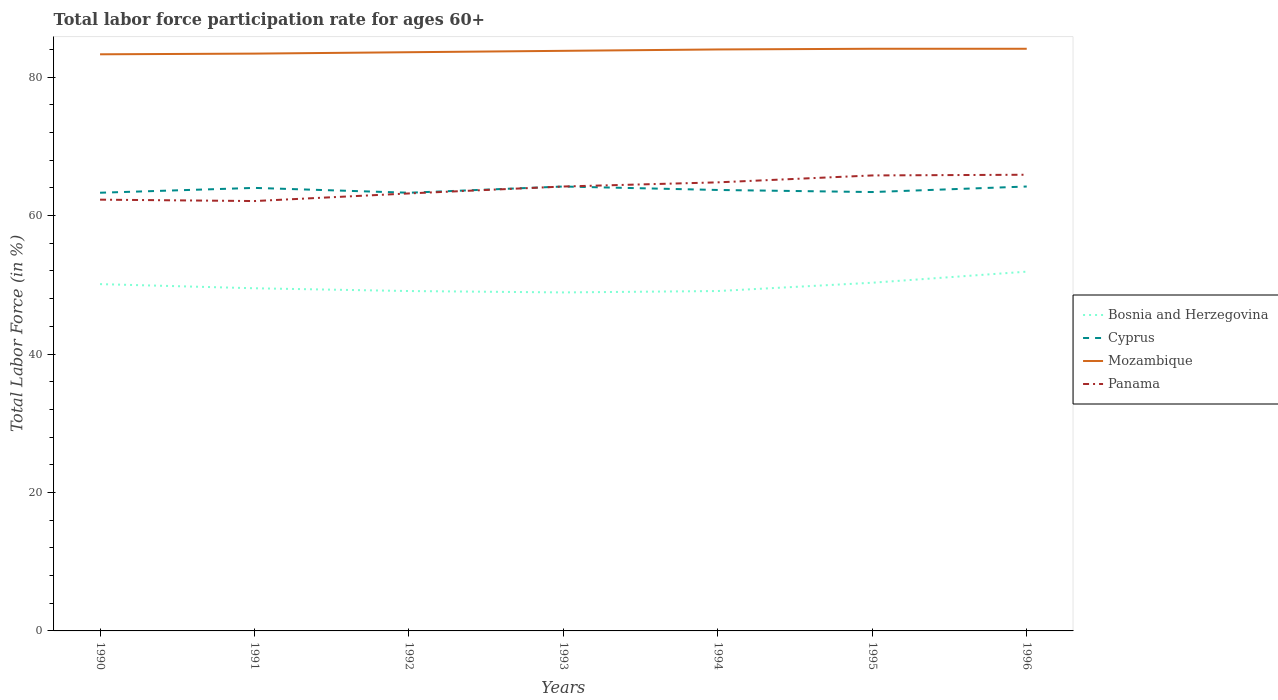How many different coloured lines are there?
Make the answer very short. 4. Does the line corresponding to Panama intersect with the line corresponding to Mozambique?
Your answer should be very brief. No. Is the number of lines equal to the number of legend labels?
Keep it short and to the point. Yes. Across all years, what is the maximum labor force participation rate in Bosnia and Herzegovina?
Your answer should be very brief. 48.9. What is the total labor force participation rate in Cyprus in the graph?
Provide a succinct answer. -0.1. What is the difference between the highest and the second highest labor force participation rate in Cyprus?
Provide a succinct answer. 0.9. What is the difference between two consecutive major ticks on the Y-axis?
Provide a succinct answer. 20. Are the values on the major ticks of Y-axis written in scientific E-notation?
Keep it short and to the point. No. Does the graph contain grids?
Provide a short and direct response. No. Where does the legend appear in the graph?
Give a very brief answer. Center right. How many legend labels are there?
Provide a short and direct response. 4. What is the title of the graph?
Give a very brief answer. Total labor force participation rate for ages 60+. Does "Korea (Democratic)" appear as one of the legend labels in the graph?
Give a very brief answer. No. What is the Total Labor Force (in %) of Bosnia and Herzegovina in 1990?
Give a very brief answer. 50.1. What is the Total Labor Force (in %) in Cyprus in 1990?
Your answer should be very brief. 63.3. What is the Total Labor Force (in %) of Mozambique in 1990?
Provide a short and direct response. 83.3. What is the Total Labor Force (in %) in Panama in 1990?
Your response must be concise. 62.3. What is the Total Labor Force (in %) of Bosnia and Herzegovina in 1991?
Offer a terse response. 49.5. What is the Total Labor Force (in %) of Mozambique in 1991?
Provide a short and direct response. 83.4. What is the Total Labor Force (in %) of Panama in 1991?
Offer a terse response. 62.1. What is the Total Labor Force (in %) in Bosnia and Herzegovina in 1992?
Provide a succinct answer. 49.1. What is the Total Labor Force (in %) in Cyprus in 1992?
Provide a short and direct response. 63.3. What is the Total Labor Force (in %) in Mozambique in 1992?
Keep it short and to the point. 83.6. What is the Total Labor Force (in %) in Panama in 1992?
Give a very brief answer. 63.2. What is the Total Labor Force (in %) in Bosnia and Herzegovina in 1993?
Provide a short and direct response. 48.9. What is the Total Labor Force (in %) in Cyprus in 1993?
Give a very brief answer. 64.2. What is the Total Labor Force (in %) in Mozambique in 1993?
Offer a terse response. 83.8. What is the Total Labor Force (in %) in Panama in 1993?
Provide a short and direct response. 64.2. What is the Total Labor Force (in %) in Bosnia and Herzegovina in 1994?
Your response must be concise. 49.1. What is the Total Labor Force (in %) in Cyprus in 1994?
Make the answer very short. 63.7. What is the Total Labor Force (in %) of Mozambique in 1994?
Ensure brevity in your answer.  84. What is the Total Labor Force (in %) in Panama in 1994?
Make the answer very short. 64.8. What is the Total Labor Force (in %) of Bosnia and Herzegovina in 1995?
Ensure brevity in your answer.  50.3. What is the Total Labor Force (in %) of Cyprus in 1995?
Offer a very short reply. 63.4. What is the Total Labor Force (in %) in Mozambique in 1995?
Make the answer very short. 84.1. What is the Total Labor Force (in %) in Panama in 1995?
Provide a short and direct response. 65.8. What is the Total Labor Force (in %) of Bosnia and Herzegovina in 1996?
Your answer should be very brief. 51.9. What is the Total Labor Force (in %) in Cyprus in 1996?
Make the answer very short. 64.2. What is the Total Labor Force (in %) of Mozambique in 1996?
Give a very brief answer. 84.1. What is the Total Labor Force (in %) of Panama in 1996?
Make the answer very short. 65.9. Across all years, what is the maximum Total Labor Force (in %) in Bosnia and Herzegovina?
Your answer should be very brief. 51.9. Across all years, what is the maximum Total Labor Force (in %) of Cyprus?
Your response must be concise. 64.2. Across all years, what is the maximum Total Labor Force (in %) of Mozambique?
Ensure brevity in your answer.  84.1. Across all years, what is the maximum Total Labor Force (in %) of Panama?
Give a very brief answer. 65.9. Across all years, what is the minimum Total Labor Force (in %) in Bosnia and Herzegovina?
Your response must be concise. 48.9. Across all years, what is the minimum Total Labor Force (in %) of Cyprus?
Your answer should be compact. 63.3. Across all years, what is the minimum Total Labor Force (in %) of Mozambique?
Your response must be concise. 83.3. Across all years, what is the minimum Total Labor Force (in %) in Panama?
Ensure brevity in your answer.  62.1. What is the total Total Labor Force (in %) in Bosnia and Herzegovina in the graph?
Your answer should be compact. 348.9. What is the total Total Labor Force (in %) in Cyprus in the graph?
Ensure brevity in your answer.  446.1. What is the total Total Labor Force (in %) of Mozambique in the graph?
Make the answer very short. 586.3. What is the total Total Labor Force (in %) of Panama in the graph?
Offer a very short reply. 448.3. What is the difference between the Total Labor Force (in %) in Bosnia and Herzegovina in 1990 and that in 1991?
Your answer should be compact. 0.6. What is the difference between the Total Labor Force (in %) of Bosnia and Herzegovina in 1990 and that in 1992?
Offer a very short reply. 1. What is the difference between the Total Labor Force (in %) of Bosnia and Herzegovina in 1990 and that in 1993?
Your answer should be compact. 1.2. What is the difference between the Total Labor Force (in %) in Cyprus in 1990 and that in 1994?
Your answer should be very brief. -0.4. What is the difference between the Total Labor Force (in %) of Mozambique in 1990 and that in 1994?
Your answer should be very brief. -0.7. What is the difference between the Total Labor Force (in %) in Bosnia and Herzegovina in 1990 and that in 1995?
Provide a short and direct response. -0.2. What is the difference between the Total Labor Force (in %) of Panama in 1990 and that in 1995?
Your response must be concise. -3.5. What is the difference between the Total Labor Force (in %) of Bosnia and Herzegovina in 1990 and that in 1996?
Offer a very short reply. -1.8. What is the difference between the Total Labor Force (in %) in Cyprus in 1990 and that in 1996?
Offer a terse response. -0.9. What is the difference between the Total Labor Force (in %) in Mozambique in 1990 and that in 1996?
Give a very brief answer. -0.8. What is the difference between the Total Labor Force (in %) in Bosnia and Herzegovina in 1991 and that in 1992?
Give a very brief answer. 0.4. What is the difference between the Total Labor Force (in %) of Cyprus in 1991 and that in 1992?
Keep it short and to the point. 0.7. What is the difference between the Total Labor Force (in %) in Panama in 1991 and that in 1992?
Your answer should be compact. -1.1. What is the difference between the Total Labor Force (in %) in Bosnia and Herzegovina in 1991 and that in 1993?
Give a very brief answer. 0.6. What is the difference between the Total Labor Force (in %) of Mozambique in 1991 and that in 1993?
Give a very brief answer. -0.4. What is the difference between the Total Labor Force (in %) of Bosnia and Herzegovina in 1991 and that in 1994?
Provide a succinct answer. 0.4. What is the difference between the Total Labor Force (in %) of Panama in 1991 and that in 1994?
Ensure brevity in your answer.  -2.7. What is the difference between the Total Labor Force (in %) of Bosnia and Herzegovina in 1991 and that in 1995?
Provide a short and direct response. -0.8. What is the difference between the Total Labor Force (in %) in Cyprus in 1991 and that in 1995?
Ensure brevity in your answer.  0.6. What is the difference between the Total Labor Force (in %) of Mozambique in 1991 and that in 1995?
Your answer should be compact. -0.7. What is the difference between the Total Labor Force (in %) of Bosnia and Herzegovina in 1991 and that in 1996?
Your response must be concise. -2.4. What is the difference between the Total Labor Force (in %) in Bosnia and Herzegovina in 1992 and that in 1993?
Your response must be concise. 0.2. What is the difference between the Total Labor Force (in %) of Panama in 1992 and that in 1993?
Ensure brevity in your answer.  -1. What is the difference between the Total Labor Force (in %) in Bosnia and Herzegovina in 1992 and that in 1994?
Ensure brevity in your answer.  0. What is the difference between the Total Labor Force (in %) in Panama in 1992 and that in 1994?
Provide a succinct answer. -1.6. What is the difference between the Total Labor Force (in %) of Cyprus in 1992 and that in 1995?
Offer a terse response. -0.1. What is the difference between the Total Labor Force (in %) in Bosnia and Herzegovina in 1992 and that in 1996?
Provide a short and direct response. -2.8. What is the difference between the Total Labor Force (in %) in Cyprus in 1992 and that in 1996?
Your response must be concise. -0.9. What is the difference between the Total Labor Force (in %) of Mozambique in 1993 and that in 1994?
Make the answer very short. -0.2. What is the difference between the Total Labor Force (in %) in Mozambique in 1993 and that in 1996?
Make the answer very short. -0.3. What is the difference between the Total Labor Force (in %) in Bosnia and Herzegovina in 1994 and that in 1995?
Keep it short and to the point. -1.2. What is the difference between the Total Labor Force (in %) of Bosnia and Herzegovina in 1994 and that in 1996?
Provide a succinct answer. -2.8. What is the difference between the Total Labor Force (in %) in Bosnia and Herzegovina in 1995 and that in 1996?
Your answer should be very brief. -1.6. What is the difference between the Total Labor Force (in %) of Cyprus in 1995 and that in 1996?
Provide a short and direct response. -0.8. What is the difference between the Total Labor Force (in %) in Mozambique in 1995 and that in 1996?
Offer a terse response. 0. What is the difference between the Total Labor Force (in %) of Bosnia and Herzegovina in 1990 and the Total Labor Force (in %) of Cyprus in 1991?
Ensure brevity in your answer.  -13.9. What is the difference between the Total Labor Force (in %) of Bosnia and Herzegovina in 1990 and the Total Labor Force (in %) of Mozambique in 1991?
Your answer should be very brief. -33.3. What is the difference between the Total Labor Force (in %) of Cyprus in 1990 and the Total Labor Force (in %) of Mozambique in 1991?
Provide a succinct answer. -20.1. What is the difference between the Total Labor Force (in %) in Cyprus in 1990 and the Total Labor Force (in %) in Panama in 1991?
Make the answer very short. 1.2. What is the difference between the Total Labor Force (in %) of Mozambique in 1990 and the Total Labor Force (in %) of Panama in 1991?
Your answer should be very brief. 21.2. What is the difference between the Total Labor Force (in %) in Bosnia and Herzegovina in 1990 and the Total Labor Force (in %) in Cyprus in 1992?
Give a very brief answer. -13.2. What is the difference between the Total Labor Force (in %) of Bosnia and Herzegovina in 1990 and the Total Labor Force (in %) of Mozambique in 1992?
Offer a very short reply. -33.5. What is the difference between the Total Labor Force (in %) of Cyprus in 1990 and the Total Labor Force (in %) of Mozambique in 1992?
Offer a terse response. -20.3. What is the difference between the Total Labor Force (in %) of Cyprus in 1990 and the Total Labor Force (in %) of Panama in 1992?
Give a very brief answer. 0.1. What is the difference between the Total Labor Force (in %) in Mozambique in 1990 and the Total Labor Force (in %) in Panama in 1992?
Keep it short and to the point. 20.1. What is the difference between the Total Labor Force (in %) in Bosnia and Herzegovina in 1990 and the Total Labor Force (in %) in Cyprus in 1993?
Give a very brief answer. -14.1. What is the difference between the Total Labor Force (in %) of Bosnia and Herzegovina in 1990 and the Total Labor Force (in %) of Mozambique in 1993?
Your answer should be compact. -33.7. What is the difference between the Total Labor Force (in %) in Bosnia and Herzegovina in 1990 and the Total Labor Force (in %) in Panama in 1993?
Make the answer very short. -14.1. What is the difference between the Total Labor Force (in %) of Cyprus in 1990 and the Total Labor Force (in %) of Mozambique in 1993?
Offer a terse response. -20.5. What is the difference between the Total Labor Force (in %) in Cyprus in 1990 and the Total Labor Force (in %) in Panama in 1993?
Ensure brevity in your answer.  -0.9. What is the difference between the Total Labor Force (in %) in Bosnia and Herzegovina in 1990 and the Total Labor Force (in %) in Cyprus in 1994?
Make the answer very short. -13.6. What is the difference between the Total Labor Force (in %) in Bosnia and Herzegovina in 1990 and the Total Labor Force (in %) in Mozambique in 1994?
Give a very brief answer. -33.9. What is the difference between the Total Labor Force (in %) in Bosnia and Herzegovina in 1990 and the Total Labor Force (in %) in Panama in 1994?
Keep it short and to the point. -14.7. What is the difference between the Total Labor Force (in %) of Cyprus in 1990 and the Total Labor Force (in %) of Mozambique in 1994?
Offer a very short reply. -20.7. What is the difference between the Total Labor Force (in %) in Cyprus in 1990 and the Total Labor Force (in %) in Panama in 1994?
Offer a very short reply. -1.5. What is the difference between the Total Labor Force (in %) in Bosnia and Herzegovina in 1990 and the Total Labor Force (in %) in Cyprus in 1995?
Keep it short and to the point. -13.3. What is the difference between the Total Labor Force (in %) of Bosnia and Herzegovina in 1990 and the Total Labor Force (in %) of Mozambique in 1995?
Provide a short and direct response. -34. What is the difference between the Total Labor Force (in %) of Bosnia and Herzegovina in 1990 and the Total Labor Force (in %) of Panama in 1995?
Your answer should be compact. -15.7. What is the difference between the Total Labor Force (in %) of Cyprus in 1990 and the Total Labor Force (in %) of Mozambique in 1995?
Your response must be concise. -20.8. What is the difference between the Total Labor Force (in %) of Cyprus in 1990 and the Total Labor Force (in %) of Panama in 1995?
Your response must be concise. -2.5. What is the difference between the Total Labor Force (in %) in Bosnia and Herzegovina in 1990 and the Total Labor Force (in %) in Cyprus in 1996?
Provide a short and direct response. -14.1. What is the difference between the Total Labor Force (in %) of Bosnia and Herzegovina in 1990 and the Total Labor Force (in %) of Mozambique in 1996?
Ensure brevity in your answer.  -34. What is the difference between the Total Labor Force (in %) of Bosnia and Herzegovina in 1990 and the Total Labor Force (in %) of Panama in 1996?
Offer a terse response. -15.8. What is the difference between the Total Labor Force (in %) in Cyprus in 1990 and the Total Labor Force (in %) in Mozambique in 1996?
Offer a terse response. -20.8. What is the difference between the Total Labor Force (in %) of Mozambique in 1990 and the Total Labor Force (in %) of Panama in 1996?
Make the answer very short. 17.4. What is the difference between the Total Labor Force (in %) in Bosnia and Herzegovina in 1991 and the Total Labor Force (in %) in Cyprus in 1992?
Provide a short and direct response. -13.8. What is the difference between the Total Labor Force (in %) of Bosnia and Herzegovina in 1991 and the Total Labor Force (in %) of Mozambique in 1992?
Ensure brevity in your answer.  -34.1. What is the difference between the Total Labor Force (in %) in Bosnia and Herzegovina in 1991 and the Total Labor Force (in %) in Panama in 1992?
Your response must be concise. -13.7. What is the difference between the Total Labor Force (in %) in Cyprus in 1991 and the Total Labor Force (in %) in Mozambique in 1992?
Make the answer very short. -19.6. What is the difference between the Total Labor Force (in %) in Mozambique in 1991 and the Total Labor Force (in %) in Panama in 1992?
Ensure brevity in your answer.  20.2. What is the difference between the Total Labor Force (in %) of Bosnia and Herzegovina in 1991 and the Total Labor Force (in %) of Cyprus in 1993?
Offer a terse response. -14.7. What is the difference between the Total Labor Force (in %) in Bosnia and Herzegovina in 1991 and the Total Labor Force (in %) in Mozambique in 1993?
Ensure brevity in your answer.  -34.3. What is the difference between the Total Labor Force (in %) in Bosnia and Herzegovina in 1991 and the Total Labor Force (in %) in Panama in 1993?
Make the answer very short. -14.7. What is the difference between the Total Labor Force (in %) in Cyprus in 1991 and the Total Labor Force (in %) in Mozambique in 1993?
Give a very brief answer. -19.8. What is the difference between the Total Labor Force (in %) of Mozambique in 1991 and the Total Labor Force (in %) of Panama in 1993?
Keep it short and to the point. 19.2. What is the difference between the Total Labor Force (in %) of Bosnia and Herzegovina in 1991 and the Total Labor Force (in %) of Cyprus in 1994?
Offer a terse response. -14.2. What is the difference between the Total Labor Force (in %) in Bosnia and Herzegovina in 1991 and the Total Labor Force (in %) in Mozambique in 1994?
Provide a succinct answer. -34.5. What is the difference between the Total Labor Force (in %) of Bosnia and Herzegovina in 1991 and the Total Labor Force (in %) of Panama in 1994?
Offer a very short reply. -15.3. What is the difference between the Total Labor Force (in %) in Mozambique in 1991 and the Total Labor Force (in %) in Panama in 1994?
Offer a very short reply. 18.6. What is the difference between the Total Labor Force (in %) of Bosnia and Herzegovina in 1991 and the Total Labor Force (in %) of Mozambique in 1995?
Keep it short and to the point. -34.6. What is the difference between the Total Labor Force (in %) of Bosnia and Herzegovina in 1991 and the Total Labor Force (in %) of Panama in 1995?
Provide a succinct answer. -16.3. What is the difference between the Total Labor Force (in %) in Cyprus in 1991 and the Total Labor Force (in %) in Mozambique in 1995?
Give a very brief answer. -20.1. What is the difference between the Total Labor Force (in %) of Bosnia and Herzegovina in 1991 and the Total Labor Force (in %) of Cyprus in 1996?
Keep it short and to the point. -14.7. What is the difference between the Total Labor Force (in %) of Bosnia and Herzegovina in 1991 and the Total Labor Force (in %) of Mozambique in 1996?
Provide a short and direct response. -34.6. What is the difference between the Total Labor Force (in %) in Bosnia and Herzegovina in 1991 and the Total Labor Force (in %) in Panama in 1996?
Offer a very short reply. -16.4. What is the difference between the Total Labor Force (in %) in Cyprus in 1991 and the Total Labor Force (in %) in Mozambique in 1996?
Your answer should be very brief. -20.1. What is the difference between the Total Labor Force (in %) of Cyprus in 1991 and the Total Labor Force (in %) of Panama in 1996?
Make the answer very short. -1.9. What is the difference between the Total Labor Force (in %) in Mozambique in 1991 and the Total Labor Force (in %) in Panama in 1996?
Offer a terse response. 17.5. What is the difference between the Total Labor Force (in %) of Bosnia and Herzegovina in 1992 and the Total Labor Force (in %) of Cyprus in 1993?
Make the answer very short. -15.1. What is the difference between the Total Labor Force (in %) of Bosnia and Herzegovina in 1992 and the Total Labor Force (in %) of Mozambique in 1993?
Give a very brief answer. -34.7. What is the difference between the Total Labor Force (in %) of Bosnia and Herzegovina in 1992 and the Total Labor Force (in %) of Panama in 1993?
Your answer should be compact. -15.1. What is the difference between the Total Labor Force (in %) in Cyprus in 1992 and the Total Labor Force (in %) in Mozambique in 1993?
Ensure brevity in your answer.  -20.5. What is the difference between the Total Labor Force (in %) in Cyprus in 1992 and the Total Labor Force (in %) in Panama in 1993?
Keep it short and to the point. -0.9. What is the difference between the Total Labor Force (in %) in Mozambique in 1992 and the Total Labor Force (in %) in Panama in 1993?
Your response must be concise. 19.4. What is the difference between the Total Labor Force (in %) in Bosnia and Herzegovina in 1992 and the Total Labor Force (in %) in Cyprus in 1994?
Keep it short and to the point. -14.6. What is the difference between the Total Labor Force (in %) of Bosnia and Herzegovina in 1992 and the Total Labor Force (in %) of Mozambique in 1994?
Your answer should be compact. -34.9. What is the difference between the Total Labor Force (in %) in Bosnia and Herzegovina in 1992 and the Total Labor Force (in %) in Panama in 1994?
Make the answer very short. -15.7. What is the difference between the Total Labor Force (in %) of Cyprus in 1992 and the Total Labor Force (in %) of Mozambique in 1994?
Your answer should be very brief. -20.7. What is the difference between the Total Labor Force (in %) of Mozambique in 1992 and the Total Labor Force (in %) of Panama in 1994?
Your answer should be compact. 18.8. What is the difference between the Total Labor Force (in %) of Bosnia and Herzegovina in 1992 and the Total Labor Force (in %) of Cyprus in 1995?
Make the answer very short. -14.3. What is the difference between the Total Labor Force (in %) in Bosnia and Herzegovina in 1992 and the Total Labor Force (in %) in Mozambique in 1995?
Ensure brevity in your answer.  -35. What is the difference between the Total Labor Force (in %) in Bosnia and Herzegovina in 1992 and the Total Labor Force (in %) in Panama in 1995?
Make the answer very short. -16.7. What is the difference between the Total Labor Force (in %) of Cyprus in 1992 and the Total Labor Force (in %) of Mozambique in 1995?
Offer a terse response. -20.8. What is the difference between the Total Labor Force (in %) in Cyprus in 1992 and the Total Labor Force (in %) in Panama in 1995?
Provide a succinct answer. -2.5. What is the difference between the Total Labor Force (in %) of Mozambique in 1992 and the Total Labor Force (in %) of Panama in 1995?
Ensure brevity in your answer.  17.8. What is the difference between the Total Labor Force (in %) of Bosnia and Herzegovina in 1992 and the Total Labor Force (in %) of Cyprus in 1996?
Your answer should be compact. -15.1. What is the difference between the Total Labor Force (in %) of Bosnia and Herzegovina in 1992 and the Total Labor Force (in %) of Mozambique in 1996?
Offer a very short reply. -35. What is the difference between the Total Labor Force (in %) of Bosnia and Herzegovina in 1992 and the Total Labor Force (in %) of Panama in 1996?
Provide a short and direct response. -16.8. What is the difference between the Total Labor Force (in %) of Cyprus in 1992 and the Total Labor Force (in %) of Mozambique in 1996?
Provide a short and direct response. -20.8. What is the difference between the Total Labor Force (in %) in Cyprus in 1992 and the Total Labor Force (in %) in Panama in 1996?
Ensure brevity in your answer.  -2.6. What is the difference between the Total Labor Force (in %) in Mozambique in 1992 and the Total Labor Force (in %) in Panama in 1996?
Offer a very short reply. 17.7. What is the difference between the Total Labor Force (in %) of Bosnia and Herzegovina in 1993 and the Total Labor Force (in %) of Cyprus in 1994?
Provide a succinct answer. -14.8. What is the difference between the Total Labor Force (in %) in Bosnia and Herzegovina in 1993 and the Total Labor Force (in %) in Mozambique in 1994?
Make the answer very short. -35.1. What is the difference between the Total Labor Force (in %) in Bosnia and Herzegovina in 1993 and the Total Labor Force (in %) in Panama in 1994?
Your response must be concise. -15.9. What is the difference between the Total Labor Force (in %) of Cyprus in 1993 and the Total Labor Force (in %) of Mozambique in 1994?
Keep it short and to the point. -19.8. What is the difference between the Total Labor Force (in %) of Cyprus in 1993 and the Total Labor Force (in %) of Panama in 1994?
Make the answer very short. -0.6. What is the difference between the Total Labor Force (in %) in Mozambique in 1993 and the Total Labor Force (in %) in Panama in 1994?
Your answer should be very brief. 19. What is the difference between the Total Labor Force (in %) in Bosnia and Herzegovina in 1993 and the Total Labor Force (in %) in Cyprus in 1995?
Provide a short and direct response. -14.5. What is the difference between the Total Labor Force (in %) of Bosnia and Herzegovina in 1993 and the Total Labor Force (in %) of Mozambique in 1995?
Provide a short and direct response. -35.2. What is the difference between the Total Labor Force (in %) in Bosnia and Herzegovina in 1993 and the Total Labor Force (in %) in Panama in 1995?
Your response must be concise. -16.9. What is the difference between the Total Labor Force (in %) in Cyprus in 1993 and the Total Labor Force (in %) in Mozambique in 1995?
Offer a terse response. -19.9. What is the difference between the Total Labor Force (in %) in Bosnia and Herzegovina in 1993 and the Total Labor Force (in %) in Cyprus in 1996?
Your answer should be very brief. -15.3. What is the difference between the Total Labor Force (in %) in Bosnia and Herzegovina in 1993 and the Total Labor Force (in %) in Mozambique in 1996?
Your answer should be compact. -35.2. What is the difference between the Total Labor Force (in %) of Bosnia and Herzegovina in 1993 and the Total Labor Force (in %) of Panama in 1996?
Your response must be concise. -17. What is the difference between the Total Labor Force (in %) of Cyprus in 1993 and the Total Labor Force (in %) of Mozambique in 1996?
Ensure brevity in your answer.  -19.9. What is the difference between the Total Labor Force (in %) of Cyprus in 1993 and the Total Labor Force (in %) of Panama in 1996?
Your answer should be compact. -1.7. What is the difference between the Total Labor Force (in %) in Mozambique in 1993 and the Total Labor Force (in %) in Panama in 1996?
Your answer should be compact. 17.9. What is the difference between the Total Labor Force (in %) in Bosnia and Herzegovina in 1994 and the Total Labor Force (in %) in Cyprus in 1995?
Your response must be concise. -14.3. What is the difference between the Total Labor Force (in %) in Bosnia and Herzegovina in 1994 and the Total Labor Force (in %) in Mozambique in 1995?
Your answer should be compact. -35. What is the difference between the Total Labor Force (in %) in Bosnia and Herzegovina in 1994 and the Total Labor Force (in %) in Panama in 1995?
Your answer should be compact. -16.7. What is the difference between the Total Labor Force (in %) of Cyprus in 1994 and the Total Labor Force (in %) of Mozambique in 1995?
Make the answer very short. -20.4. What is the difference between the Total Labor Force (in %) in Mozambique in 1994 and the Total Labor Force (in %) in Panama in 1995?
Give a very brief answer. 18.2. What is the difference between the Total Labor Force (in %) in Bosnia and Herzegovina in 1994 and the Total Labor Force (in %) in Cyprus in 1996?
Keep it short and to the point. -15.1. What is the difference between the Total Labor Force (in %) in Bosnia and Herzegovina in 1994 and the Total Labor Force (in %) in Mozambique in 1996?
Provide a short and direct response. -35. What is the difference between the Total Labor Force (in %) in Bosnia and Herzegovina in 1994 and the Total Labor Force (in %) in Panama in 1996?
Your answer should be very brief. -16.8. What is the difference between the Total Labor Force (in %) of Cyprus in 1994 and the Total Labor Force (in %) of Mozambique in 1996?
Make the answer very short. -20.4. What is the difference between the Total Labor Force (in %) of Bosnia and Herzegovina in 1995 and the Total Labor Force (in %) of Mozambique in 1996?
Give a very brief answer. -33.8. What is the difference between the Total Labor Force (in %) of Bosnia and Herzegovina in 1995 and the Total Labor Force (in %) of Panama in 1996?
Your answer should be very brief. -15.6. What is the difference between the Total Labor Force (in %) in Cyprus in 1995 and the Total Labor Force (in %) in Mozambique in 1996?
Offer a very short reply. -20.7. What is the difference between the Total Labor Force (in %) of Cyprus in 1995 and the Total Labor Force (in %) of Panama in 1996?
Offer a terse response. -2.5. What is the average Total Labor Force (in %) of Bosnia and Herzegovina per year?
Provide a succinct answer. 49.84. What is the average Total Labor Force (in %) of Cyprus per year?
Offer a very short reply. 63.73. What is the average Total Labor Force (in %) of Mozambique per year?
Ensure brevity in your answer.  83.76. What is the average Total Labor Force (in %) in Panama per year?
Your response must be concise. 64.04. In the year 1990, what is the difference between the Total Labor Force (in %) in Bosnia and Herzegovina and Total Labor Force (in %) in Mozambique?
Make the answer very short. -33.2. In the year 1990, what is the difference between the Total Labor Force (in %) of Cyprus and Total Labor Force (in %) of Panama?
Provide a succinct answer. 1. In the year 1990, what is the difference between the Total Labor Force (in %) in Mozambique and Total Labor Force (in %) in Panama?
Your answer should be compact. 21. In the year 1991, what is the difference between the Total Labor Force (in %) in Bosnia and Herzegovina and Total Labor Force (in %) in Mozambique?
Give a very brief answer. -33.9. In the year 1991, what is the difference between the Total Labor Force (in %) in Bosnia and Herzegovina and Total Labor Force (in %) in Panama?
Provide a succinct answer. -12.6. In the year 1991, what is the difference between the Total Labor Force (in %) in Cyprus and Total Labor Force (in %) in Mozambique?
Keep it short and to the point. -19.4. In the year 1991, what is the difference between the Total Labor Force (in %) in Mozambique and Total Labor Force (in %) in Panama?
Provide a short and direct response. 21.3. In the year 1992, what is the difference between the Total Labor Force (in %) of Bosnia and Herzegovina and Total Labor Force (in %) of Mozambique?
Your response must be concise. -34.5. In the year 1992, what is the difference between the Total Labor Force (in %) in Bosnia and Herzegovina and Total Labor Force (in %) in Panama?
Your answer should be compact. -14.1. In the year 1992, what is the difference between the Total Labor Force (in %) in Cyprus and Total Labor Force (in %) in Mozambique?
Your answer should be very brief. -20.3. In the year 1992, what is the difference between the Total Labor Force (in %) in Mozambique and Total Labor Force (in %) in Panama?
Your answer should be compact. 20.4. In the year 1993, what is the difference between the Total Labor Force (in %) of Bosnia and Herzegovina and Total Labor Force (in %) of Cyprus?
Provide a succinct answer. -15.3. In the year 1993, what is the difference between the Total Labor Force (in %) in Bosnia and Herzegovina and Total Labor Force (in %) in Mozambique?
Make the answer very short. -34.9. In the year 1993, what is the difference between the Total Labor Force (in %) in Bosnia and Herzegovina and Total Labor Force (in %) in Panama?
Make the answer very short. -15.3. In the year 1993, what is the difference between the Total Labor Force (in %) in Cyprus and Total Labor Force (in %) in Mozambique?
Ensure brevity in your answer.  -19.6. In the year 1993, what is the difference between the Total Labor Force (in %) in Mozambique and Total Labor Force (in %) in Panama?
Make the answer very short. 19.6. In the year 1994, what is the difference between the Total Labor Force (in %) in Bosnia and Herzegovina and Total Labor Force (in %) in Cyprus?
Your response must be concise. -14.6. In the year 1994, what is the difference between the Total Labor Force (in %) of Bosnia and Herzegovina and Total Labor Force (in %) of Mozambique?
Provide a succinct answer. -34.9. In the year 1994, what is the difference between the Total Labor Force (in %) of Bosnia and Herzegovina and Total Labor Force (in %) of Panama?
Make the answer very short. -15.7. In the year 1994, what is the difference between the Total Labor Force (in %) in Cyprus and Total Labor Force (in %) in Mozambique?
Offer a terse response. -20.3. In the year 1995, what is the difference between the Total Labor Force (in %) in Bosnia and Herzegovina and Total Labor Force (in %) in Mozambique?
Offer a terse response. -33.8. In the year 1995, what is the difference between the Total Labor Force (in %) in Bosnia and Herzegovina and Total Labor Force (in %) in Panama?
Keep it short and to the point. -15.5. In the year 1995, what is the difference between the Total Labor Force (in %) of Cyprus and Total Labor Force (in %) of Mozambique?
Your answer should be very brief. -20.7. In the year 1995, what is the difference between the Total Labor Force (in %) in Cyprus and Total Labor Force (in %) in Panama?
Your answer should be compact. -2.4. In the year 1995, what is the difference between the Total Labor Force (in %) in Mozambique and Total Labor Force (in %) in Panama?
Your answer should be very brief. 18.3. In the year 1996, what is the difference between the Total Labor Force (in %) of Bosnia and Herzegovina and Total Labor Force (in %) of Cyprus?
Ensure brevity in your answer.  -12.3. In the year 1996, what is the difference between the Total Labor Force (in %) in Bosnia and Herzegovina and Total Labor Force (in %) in Mozambique?
Ensure brevity in your answer.  -32.2. In the year 1996, what is the difference between the Total Labor Force (in %) in Cyprus and Total Labor Force (in %) in Mozambique?
Offer a terse response. -19.9. In the year 1996, what is the difference between the Total Labor Force (in %) in Cyprus and Total Labor Force (in %) in Panama?
Your response must be concise. -1.7. In the year 1996, what is the difference between the Total Labor Force (in %) of Mozambique and Total Labor Force (in %) of Panama?
Make the answer very short. 18.2. What is the ratio of the Total Labor Force (in %) in Bosnia and Herzegovina in 1990 to that in 1991?
Offer a very short reply. 1.01. What is the ratio of the Total Labor Force (in %) in Cyprus in 1990 to that in 1991?
Give a very brief answer. 0.99. What is the ratio of the Total Labor Force (in %) of Bosnia and Herzegovina in 1990 to that in 1992?
Provide a succinct answer. 1.02. What is the ratio of the Total Labor Force (in %) in Cyprus in 1990 to that in 1992?
Keep it short and to the point. 1. What is the ratio of the Total Labor Force (in %) in Mozambique in 1990 to that in 1992?
Your answer should be very brief. 1. What is the ratio of the Total Labor Force (in %) of Panama in 1990 to that in 1992?
Provide a succinct answer. 0.99. What is the ratio of the Total Labor Force (in %) of Bosnia and Herzegovina in 1990 to that in 1993?
Your answer should be very brief. 1.02. What is the ratio of the Total Labor Force (in %) of Cyprus in 1990 to that in 1993?
Your answer should be compact. 0.99. What is the ratio of the Total Labor Force (in %) of Panama in 1990 to that in 1993?
Keep it short and to the point. 0.97. What is the ratio of the Total Labor Force (in %) in Bosnia and Herzegovina in 1990 to that in 1994?
Provide a succinct answer. 1.02. What is the ratio of the Total Labor Force (in %) of Mozambique in 1990 to that in 1994?
Give a very brief answer. 0.99. What is the ratio of the Total Labor Force (in %) in Panama in 1990 to that in 1994?
Your answer should be compact. 0.96. What is the ratio of the Total Labor Force (in %) in Cyprus in 1990 to that in 1995?
Ensure brevity in your answer.  1. What is the ratio of the Total Labor Force (in %) in Mozambique in 1990 to that in 1995?
Your answer should be compact. 0.99. What is the ratio of the Total Labor Force (in %) in Panama in 1990 to that in 1995?
Ensure brevity in your answer.  0.95. What is the ratio of the Total Labor Force (in %) in Bosnia and Herzegovina in 1990 to that in 1996?
Ensure brevity in your answer.  0.97. What is the ratio of the Total Labor Force (in %) in Mozambique in 1990 to that in 1996?
Your response must be concise. 0.99. What is the ratio of the Total Labor Force (in %) of Panama in 1990 to that in 1996?
Keep it short and to the point. 0.95. What is the ratio of the Total Labor Force (in %) of Cyprus in 1991 to that in 1992?
Your answer should be compact. 1.01. What is the ratio of the Total Labor Force (in %) of Panama in 1991 to that in 1992?
Provide a succinct answer. 0.98. What is the ratio of the Total Labor Force (in %) in Bosnia and Herzegovina in 1991 to that in 1993?
Your answer should be very brief. 1.01. What is the ratio of the Total Labor Force (in %) of Panama in 1991 to that in 1993?
Provide a succinct answer. 0.97. What is the ratio of the Total Labor Force (in %) of Panama in 1991 to that in 1994?
Your response must be concise. 0.96. What is the ratio of the Total Labor Force (in %) in Bosnia and Herzegovina in 1991 to that in 1995?
Provide a succinct answer. 0.98. What is the ratio of the Total Labor Force (in %) of Cyprus in 1991 to that in 1995?
Your answer should be very brief. 1.01. What is the ratio of the Total Labor Force (in %) of Panama in 1991 to that in 1995?
Provide a succinct answer. 0.94. What is the ratio of the Total Labor Force (in %) in Bosnia and Herzegovina in 1991 to that in 1996?
Give a very brief answer. 0.95. What is the ratio of the Total Labor Force (in %) of Panama in 1991 to that in 1996?
Make the answer very short. 0.94. What is the ratio of the Total Labor Force (in %) of Bosnia and Herzegovina in 1992 to that in 1993?
Offer a terse response. 1. What is the ratio of the Total Labor Force (in %) of Mozambique in 1992 to that in 1993?
Your answer should be very brief. 1. What is the ratio of the Total Labor Force (in %) in Panama in 1992 to that in 1993?
Your response must be concise. 0.98. What is the ratio of the Total Labor Force (in %) of Cyprus in 1992 to that in 1994?
Provide a succinct answer. 0.99. What is the ratio of the Total Labor Force (in %) of Mozambique in 1992 to that in 1994?
Ensure brevity in your answer.  1. What is the ratio of the Total Labor Force (in %) of Panama in 1992 to that in 1994?
Make the answer very short. 0.98. What is the ratio of the Total Labor Force (in %) in Bosnia and Herzegovina in 1992 to that in 1995?
Provide a short and direct response. 0.98. What is the ratio of the Total Labor Force (in %) of Cyprus in 1992 to that in 1995?
Your answer should be compact. 1. What is the ratio of the Total Labor Force (in %) of Mozambique in 1992 to that in 1995?
Your response must be concise. 0.99. What is the ratio of the Total Labor Force (in %) of Panama in 1992 to that in 1995?
Make the answer very short. 0.96. What is the ratio of the Total Labor Force (in %) in Bosnia and Herzegovina in 1992 to that in 1996?
Your response must be concise. 0.95. What is the ratio of the Total Labor Force (in %) of Cyprus in 1993 to that in 1994?
Make the answer very short. 1.01. What is the ratio of the Total Labor Force (in %) of Panama in 1993 to that in 1994?
Provide a succinct answer. 0.99. What is the ratio of the Total Labor Force (in %) of Bosnia and Herzegovina in 1993 to that in 1995?
Give a very brief answer. 0.97. What is the ratio of the Total Labor Force (in %) of Cyprus in 1993 to that in 1995?
Provide a short and direct response. 1.01. What is the ratio of the Total Labor Force (in %) in Mozambique in 1993 to that in 1995?
Give a very brief answer. 1. What is the ratio of the Total Labor Force (in %) in Panama in 1993 to that in 1995?
Offer a very short reply. 0.98. What is the ratio of the Total Labor Force (in %) of Bosnia and Herzegovina in 1993 to that in 1996?
Provide a short and direct response. 0.94. What is the ratio of the Total Labor Force (in %) in Panama in 1993 to that in 1996?
Keep it short and to the point. 0.97. What is the ratio of the Total Labor Force (in %) of Bosnia and Herzegovina in 1994 to that in 1995?
Ensure brevity in your answer.  0.98. What is the ratio of the Total Labor Force (in %) in Cyprus in 1994 to that in 1995?
Your answer should be compact. 1. What is the ratio of the Total Labor Force (in %) in Mozambique in 1994 to that in 1995?
Provide a short and direct response. 1. What is the ratio of the Total Labor Force (in %) in Panama in 1994 to that in 1995?
Offer a very short reply. 0.98. What is the ratio of the Total Labor Force (in %) of Bosnia and Herzegovina in 1994 to that in 1996?
Ensure brevity in your answer.  0.95. What is the ratio of the Total Labor Force (in %) of Panama in 1994 to that in 1996?
Keep it short and to the point. 0.98. What is the ratio of the Total Labor Force (in %) of Bosnia and Herzegovina in 1995 to that in 1996?
Provide a succinct answer. 0.97. What is the ratio of the Total Labor Force (in %) of Cyprus in 1995 to that in 1996?
Keep it short and to the point. 0.99. What is the ratio of the Total Labor Force (in %) of Mozambique in 1995 to that in 1996?
Offer a terse response. 1. What is the ratio of the Total Labor Force (in %) in Panama in 1995 to that in 1996?
Your answer should be very brief. 1. What is the difference between the highest and the second highest Total Labor Force (in %) of Bosnia and Herzegovina?
Ensure brevity in your answer.  1.6. What is the difference between the highest and the second highest Total Labor Force (in %) in Cyprus?
Your answer should be very brief. 0. What is the difference between the highest and the second highest Total Labor Force (in %) in Mozambique?
Make the answer very short. 0. What is the difference between the highest and the second highest Total Labor Force (in %) of Panama?
Provide a short and direct response. 0.1. What is the difference between the highest and the lowest Total Labor Force (in %) in Bosnia and Herzegovina?
Make the answer very short. 3. What is the difference between the highest and the lowest Total Labor Force (in %) in Cyprus?
Keep it short and to the point. 0.9. What is the difference between the highest and the lowest Total Labor Force (in %) of Panama?
Offer a very short reply. 3.8. 